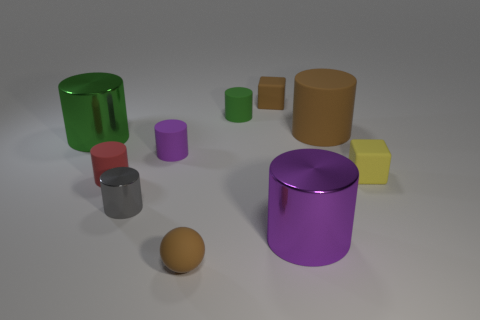There is a large rubber cylinder in front of the tiny green matte cylinder that is to the left of the small yellow rubber thing; what number of tiny rubber blocks are to the right of it?
Ensure brevity in your answer.  1. What is the material of the brown thing that is to the left of the big brown cylinder and behind the brown sphere?
Offer a very short reply. Rubber. The tiny rubber sphere has what color?
Ensure brevity in your answer.  Brown. Are there more large green shiny things on the left side of the tiny brown sphere than small metallic cylinders right of the small purple cylinder?
Keep it short and to the point. Yes. There is a big metal cylinder that is in front of the red matte thing; what color is it?
Offer a very short reply. Purple. Is the size of the brown rubber object that is in front of the small purple matte cylinder the same as the purple object that is in front of the small red object?
Make the answer very short. No. How many objects are yellow cubes or tiny brown objects?
Offer a very short reply. 3. There is a green object to the left of the small green matte thing behind the brown ball; what is its material?
Your answer should be compact. Metal. How many red things are the same shape as the gray metallic thing?
Your answer should be very brief. 1. Is there a small rubber ball of the same color as the big rubber object?
Give a very brief answer. Yes. 